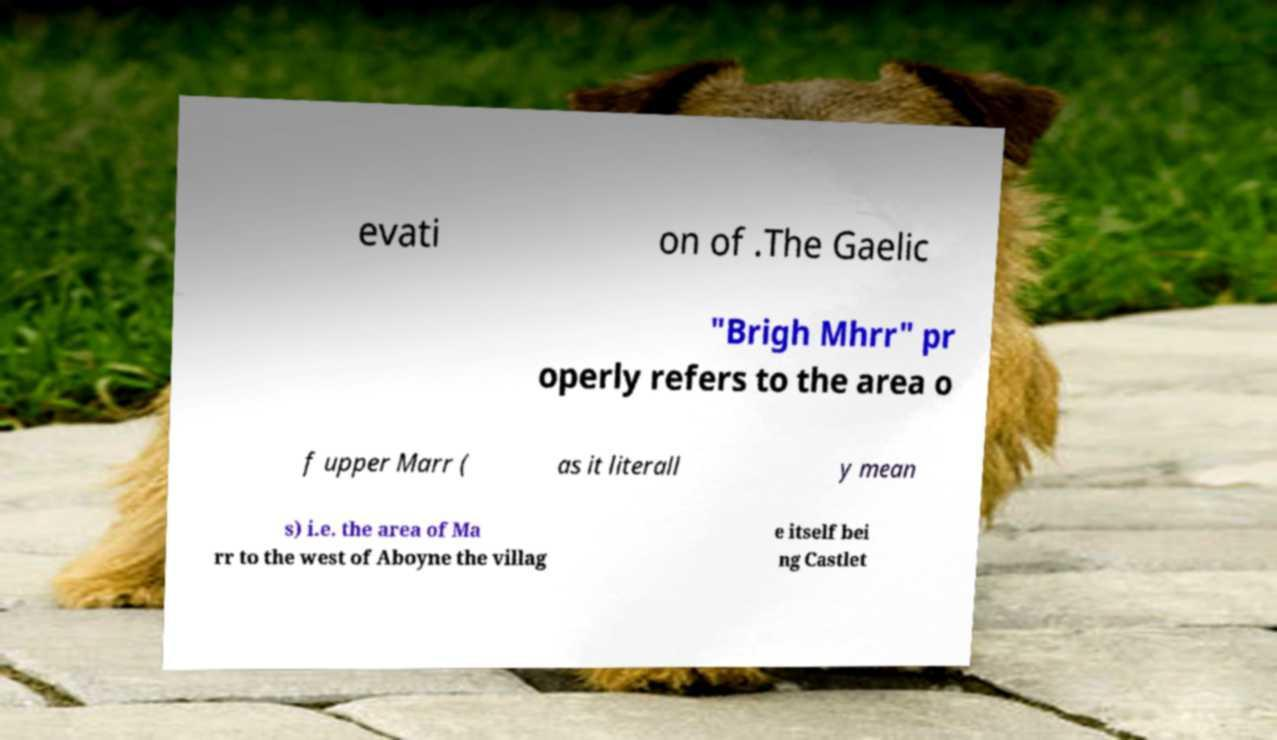For documentation purposes, I need the text within this image transcribed. Could you provide that? evati on of .The Gaelic "Brigh Mhrr" pr operly refers to the area o f upper Marr ( as it literall y mean s) i.e. the area of Ma rr to the west of Aboyne the villag e itself bei ng Castlet 